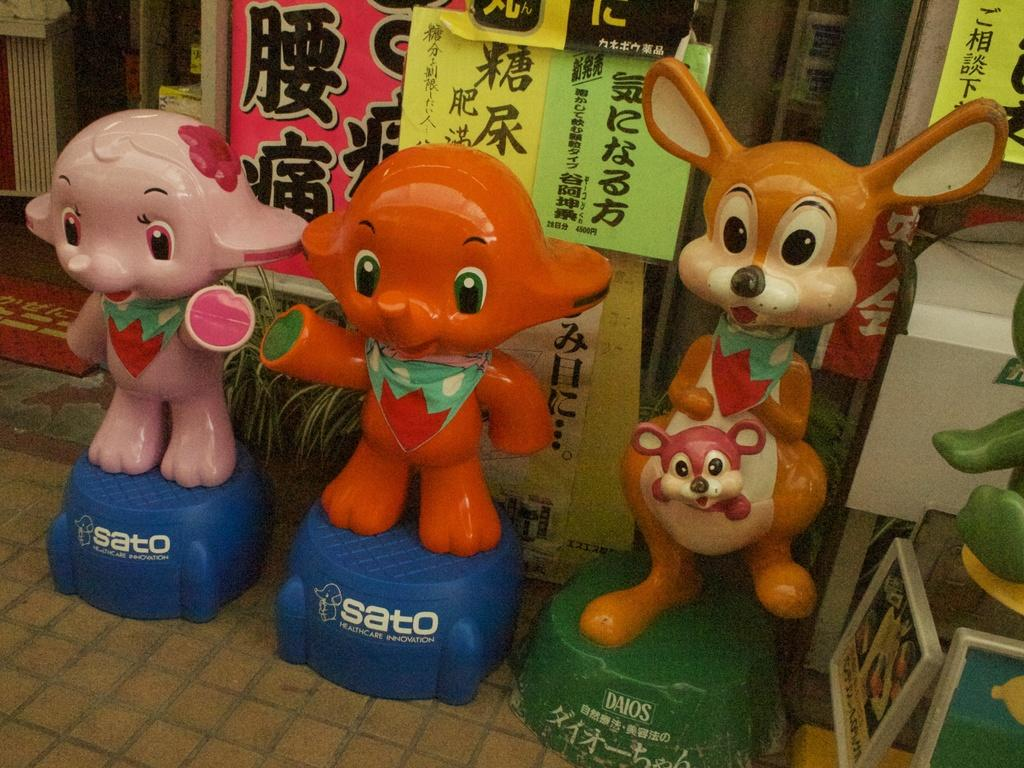What type of objects can be seen in the image? There are statues in the image. What can be seen in the background of the image? There are posters in the background of the image. What type of card can be seen in the image? There is no card present in the image; it features statues and posters. What type of harmony is depicted in the image? The image does not depict any specific harmony; it features statues and posters. 